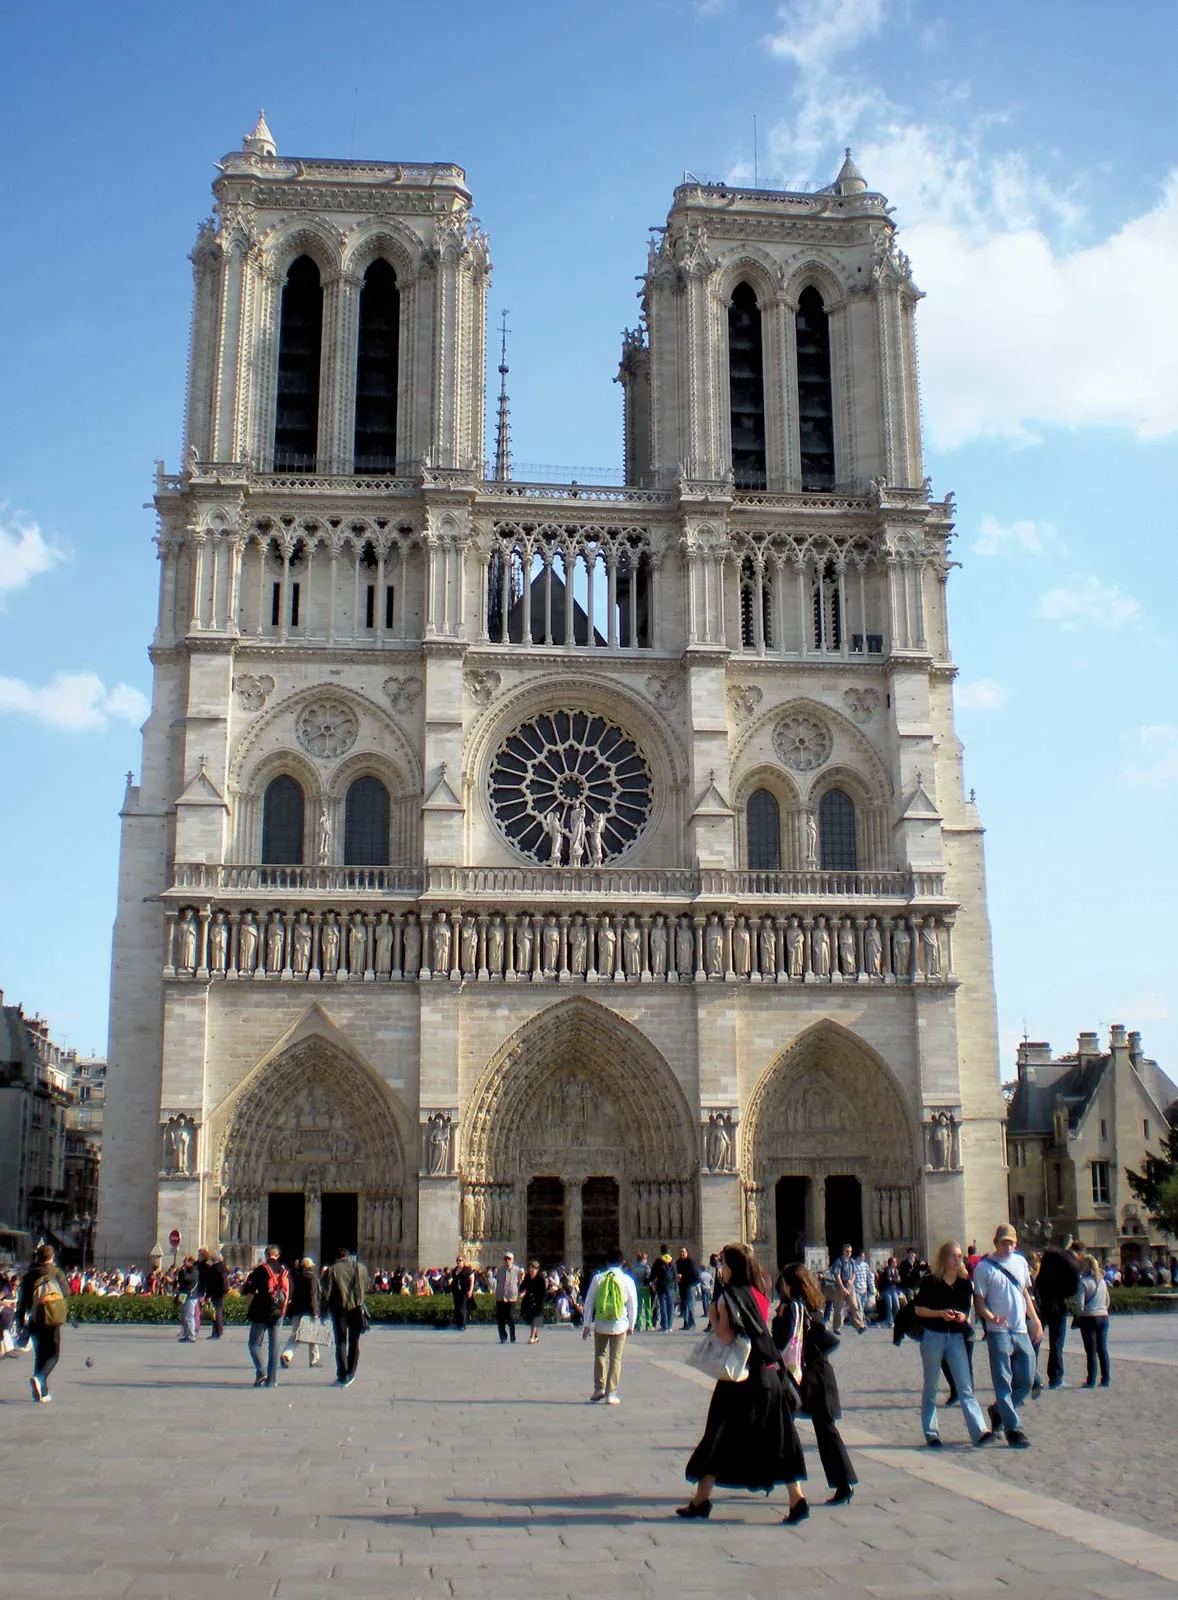Can you describe the architecture of this cathedral? Notre Dame Cathedral is a quintessential example of French Gothic architecture. Its facade is marked by two colossal towers, each reaching around 69 meters in height. The central rose window, a stunning piece of medieval stained glass, is flanked by elaborate stone carvings and statues of saints. The three portals at the entrance are adorned with intricate sculptures depicting biblical scenes. The cathedral’s flying buttresses are a remarkable feature, providing both structural support and aesthetic charm. Inside, the vaulted ceilings, ribbed pillars, and a series of smaller stained glass windows add to the immense beauty and religious symbolism of the structure. What can we see within the intricate details of the rose window? The rose window of Notre Dame Cathedral is a masterpiece of Gothic art. It depicts scenes from the Last Judgment and various saints, apostles, and biblical tales. The vivid stained glass pieces are arranged in a circular form, creating a mesmerizing kaleidoscope of colors. At the center, Christ is often depicted in glory, surrounded by angelic figures. Each section of the window tells a story, serving both as a religious narrative and as an educational tool for the medieval illiterate population. The window’s intricate tracery and vibrant hues are a testament to the craftsmanship and artistic vision of the medieval artisans. 